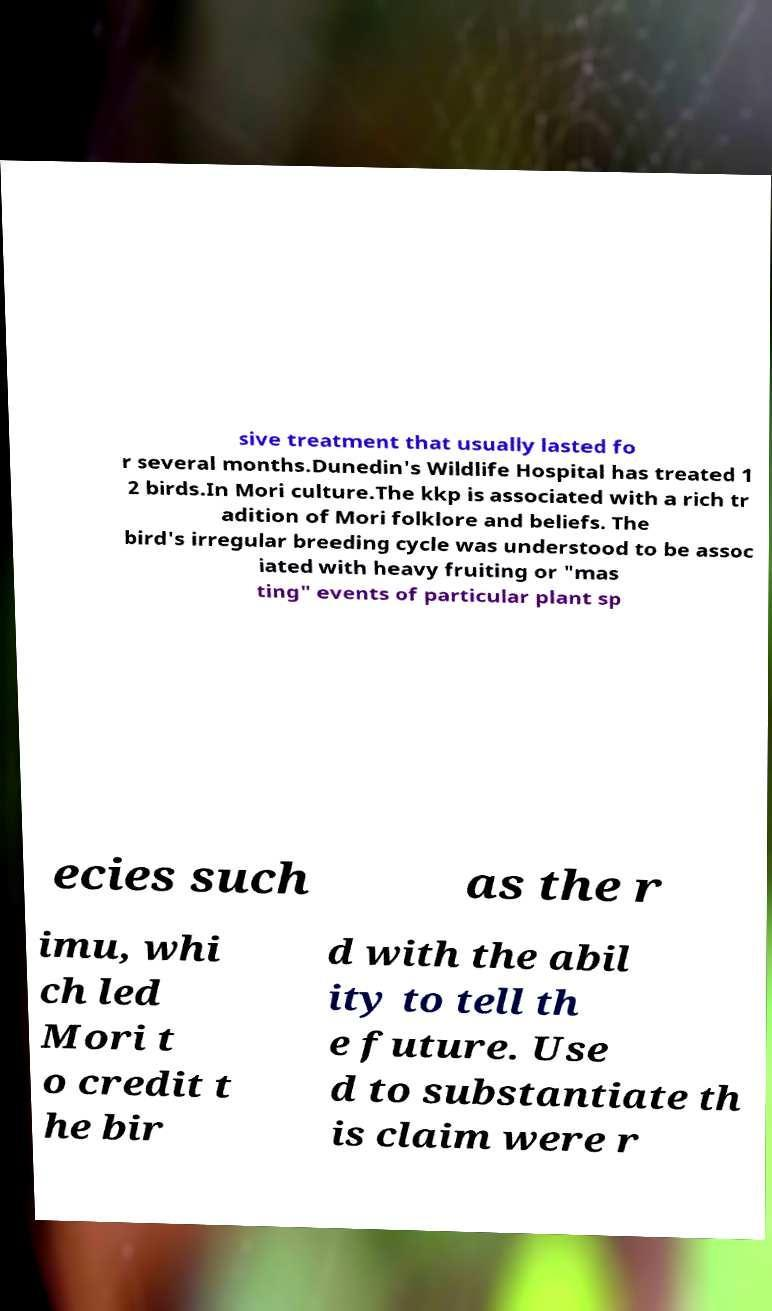I need the written content from this picture converted into text. Can you do that? sive treatment that usually lasted fo r several months.Dunedin's Wildlife Hospital has treated 1 2 birds.In Mori culture.The kkp is associated with a rich tr adition of Mori folklore and beliefs. The bird's irregular breeding cycle was understood to be assoc iated with heavy fruiting or "mas ting" events of particular plant sp ecies such as the r imu, whi ch led Mori t o credit t he bir d with the abil ity to tell th e future. Use d to substantiate th is claim were r 